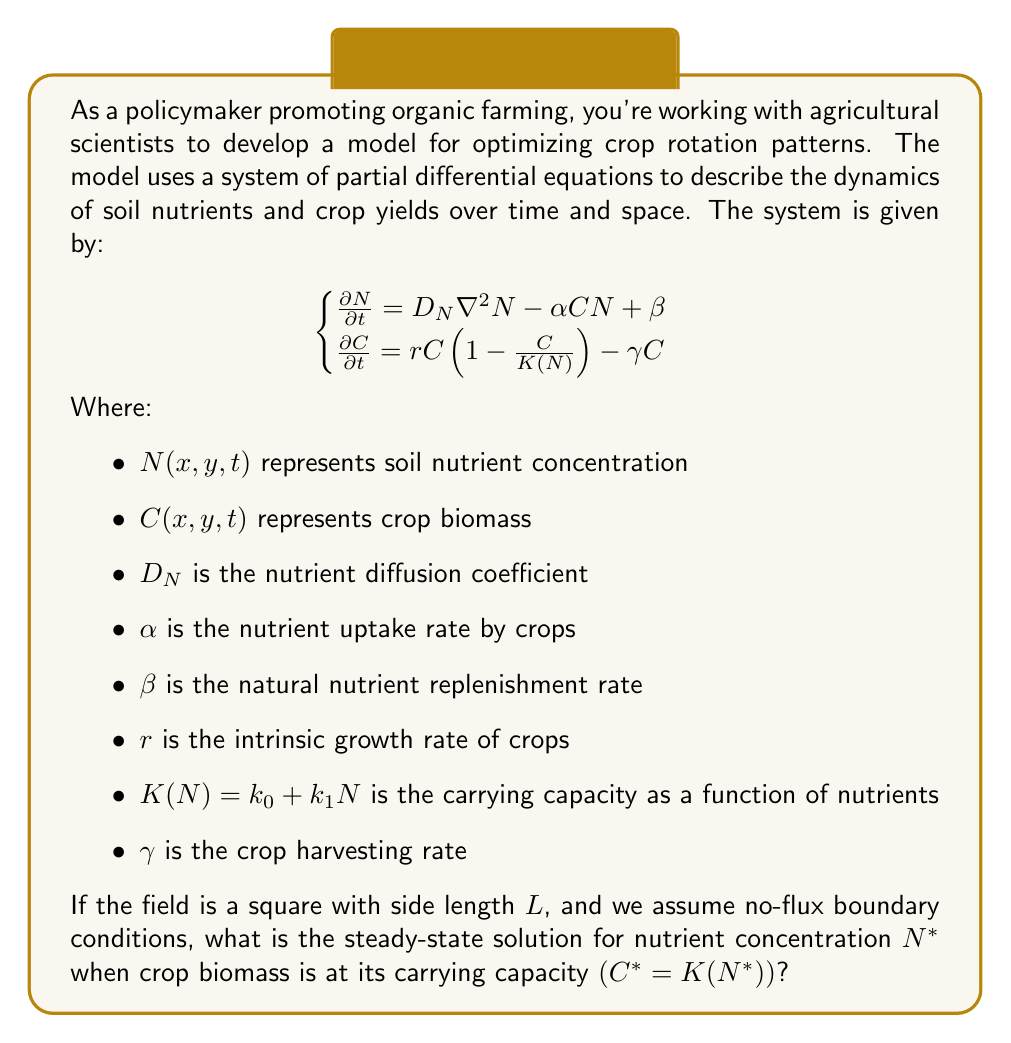Teach me how to tackle this problem. To solve this problem, we'll follow these steps:

1) First, we need to consider the steady-state conditions. At steady-state, the time derivatives are zero:

   $$\begin{cases}
   0 = D_N \nabla^2 N^* - \alpha C^* N^* + \beta \\
   0 = r C^* \left(1 - \frac{C^*}{K(N^*)}\right) - \gamma C^*
   \end{cases}$$

2) From the second equation, we're given that $C^* = K(N^*)$ at steady-state. Substituting this into the first equation:

   $$0 = D_N \nabla^2 N^* - \alpha K(N^*) N^* + \beta$$

3) We're looking for a spatially uniform solution, so $\nabla^2 N^* = 0$. This simplifies our equation to:

   $$0 = - \alpha K(N^*) N^* + \beta$$

4) Substituting the expression for $K(N^*)$:

   $$0 = - \alpha (k_0 + k_1 N^*) N^* + \beta$$

5) Expanding this:

   $$0 = - \alpha k_0 N^* - \alpha k_1 (N^*)^2 + \beta$$

6) Rearranging into standard quadratic form:

   $$\alpha k_1 (N^*)^2 + \alpha k_0 N^* - \beta = 0$$

7) We can solve this using the quadratic formula: $N^* = \frac{-b \pm \sqrt{b^2 - 4ac}}{2a}$

   Where $a = \alpha k_1$, $b = \alpha k_0$, and $c = -\beta$

8) Substituting these in:

   $$N^* = \frac{-\alpha k_0 \pm \sqrt{(\alpha k_0)^2 + 4\alpha k_1 \beta}}{2\alpha k_1}$$

9) Since nutrient concentration must be non-negative, we take the positive root:

   $$N^* = \frac{-\alpha k_0 + \sqrt{(\alpha k_0)^2 + 4\alpha k_1 \beta}}{2\alpha k_1}$$

This is the steady-state solution for nutrient concentration when crop biomass is at its carrying capacity.
Answer: $$N^* = \frac{-\alpha k_0 + \sqrt{(\alpha k_0)^2 + 4\alpha k_1 \beta}}{2\alpha k_1}$$ 